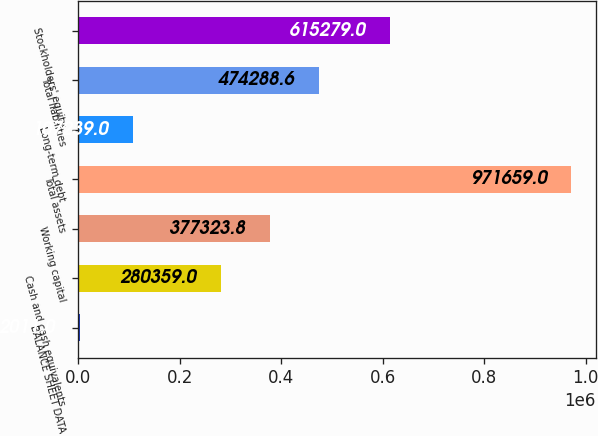Convert chart. <chart><loc_0><loc_0><loc_500><loc_500><bar_chart><fcel>BALANCE SHEET DATA<fcel>Cash and cash equivalents<fcel>Working capital<fcel>Total assets<fcel>Long-term debt<fcel>Total liabilities<fcel>Stockholders' equity<nl><fcel>2011<fcel>280359<fcel>377324<fcel>971659<fcel>107239<fcel>474289<fcel>615279<nl></chart> 